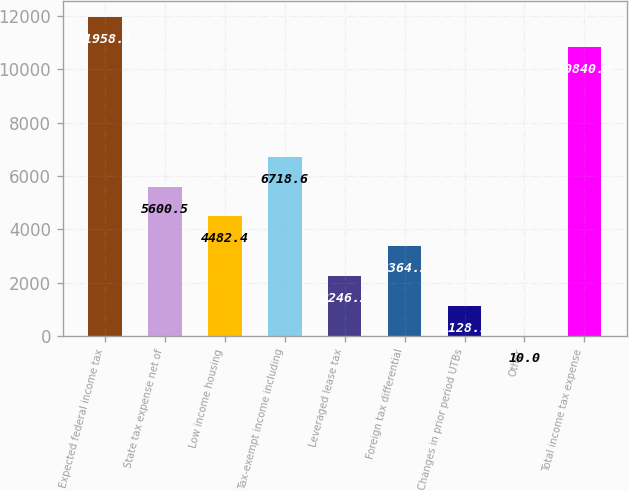Convert chart. <chart><loc_0><loc_0><loc_500><loc_500><bar_chart><fcel>Expected federal income tax<fcel>State tax expense net of<fcel>Low income housing<fcel>Tax-exempt income including<fcel>Leveraged lease tax<fcel>Foreign tax differential<fcel>Changes in prior period UTBs<fcel>Other<fcel>Total income tax expense<nl><fcel>11958.1<fcel>5600.5<fcel>4482.4<fcel>6718.6<fcel>2246.2<fcel>3364.3<fcel>1128.1<fcel>10<fcel>10840<nl></chart> 